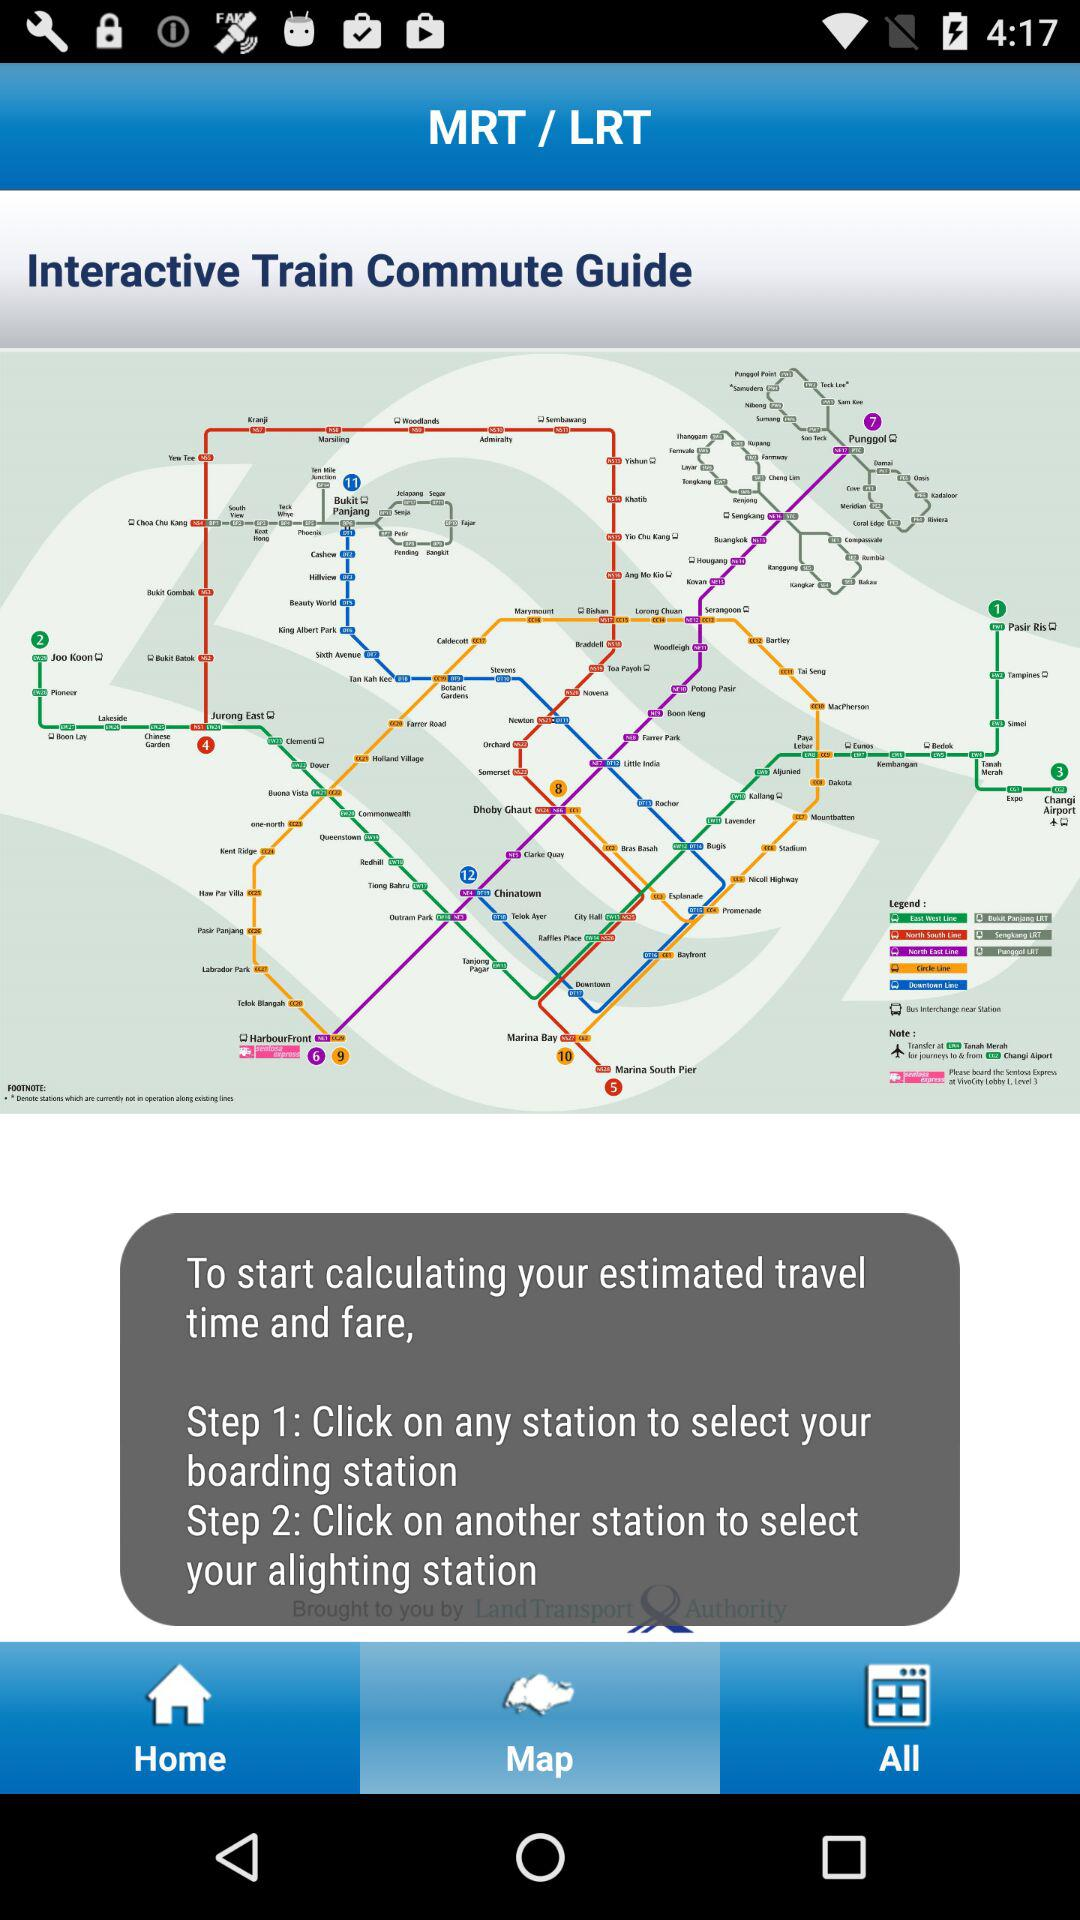What tab is selected? The selected tab is "Map". 